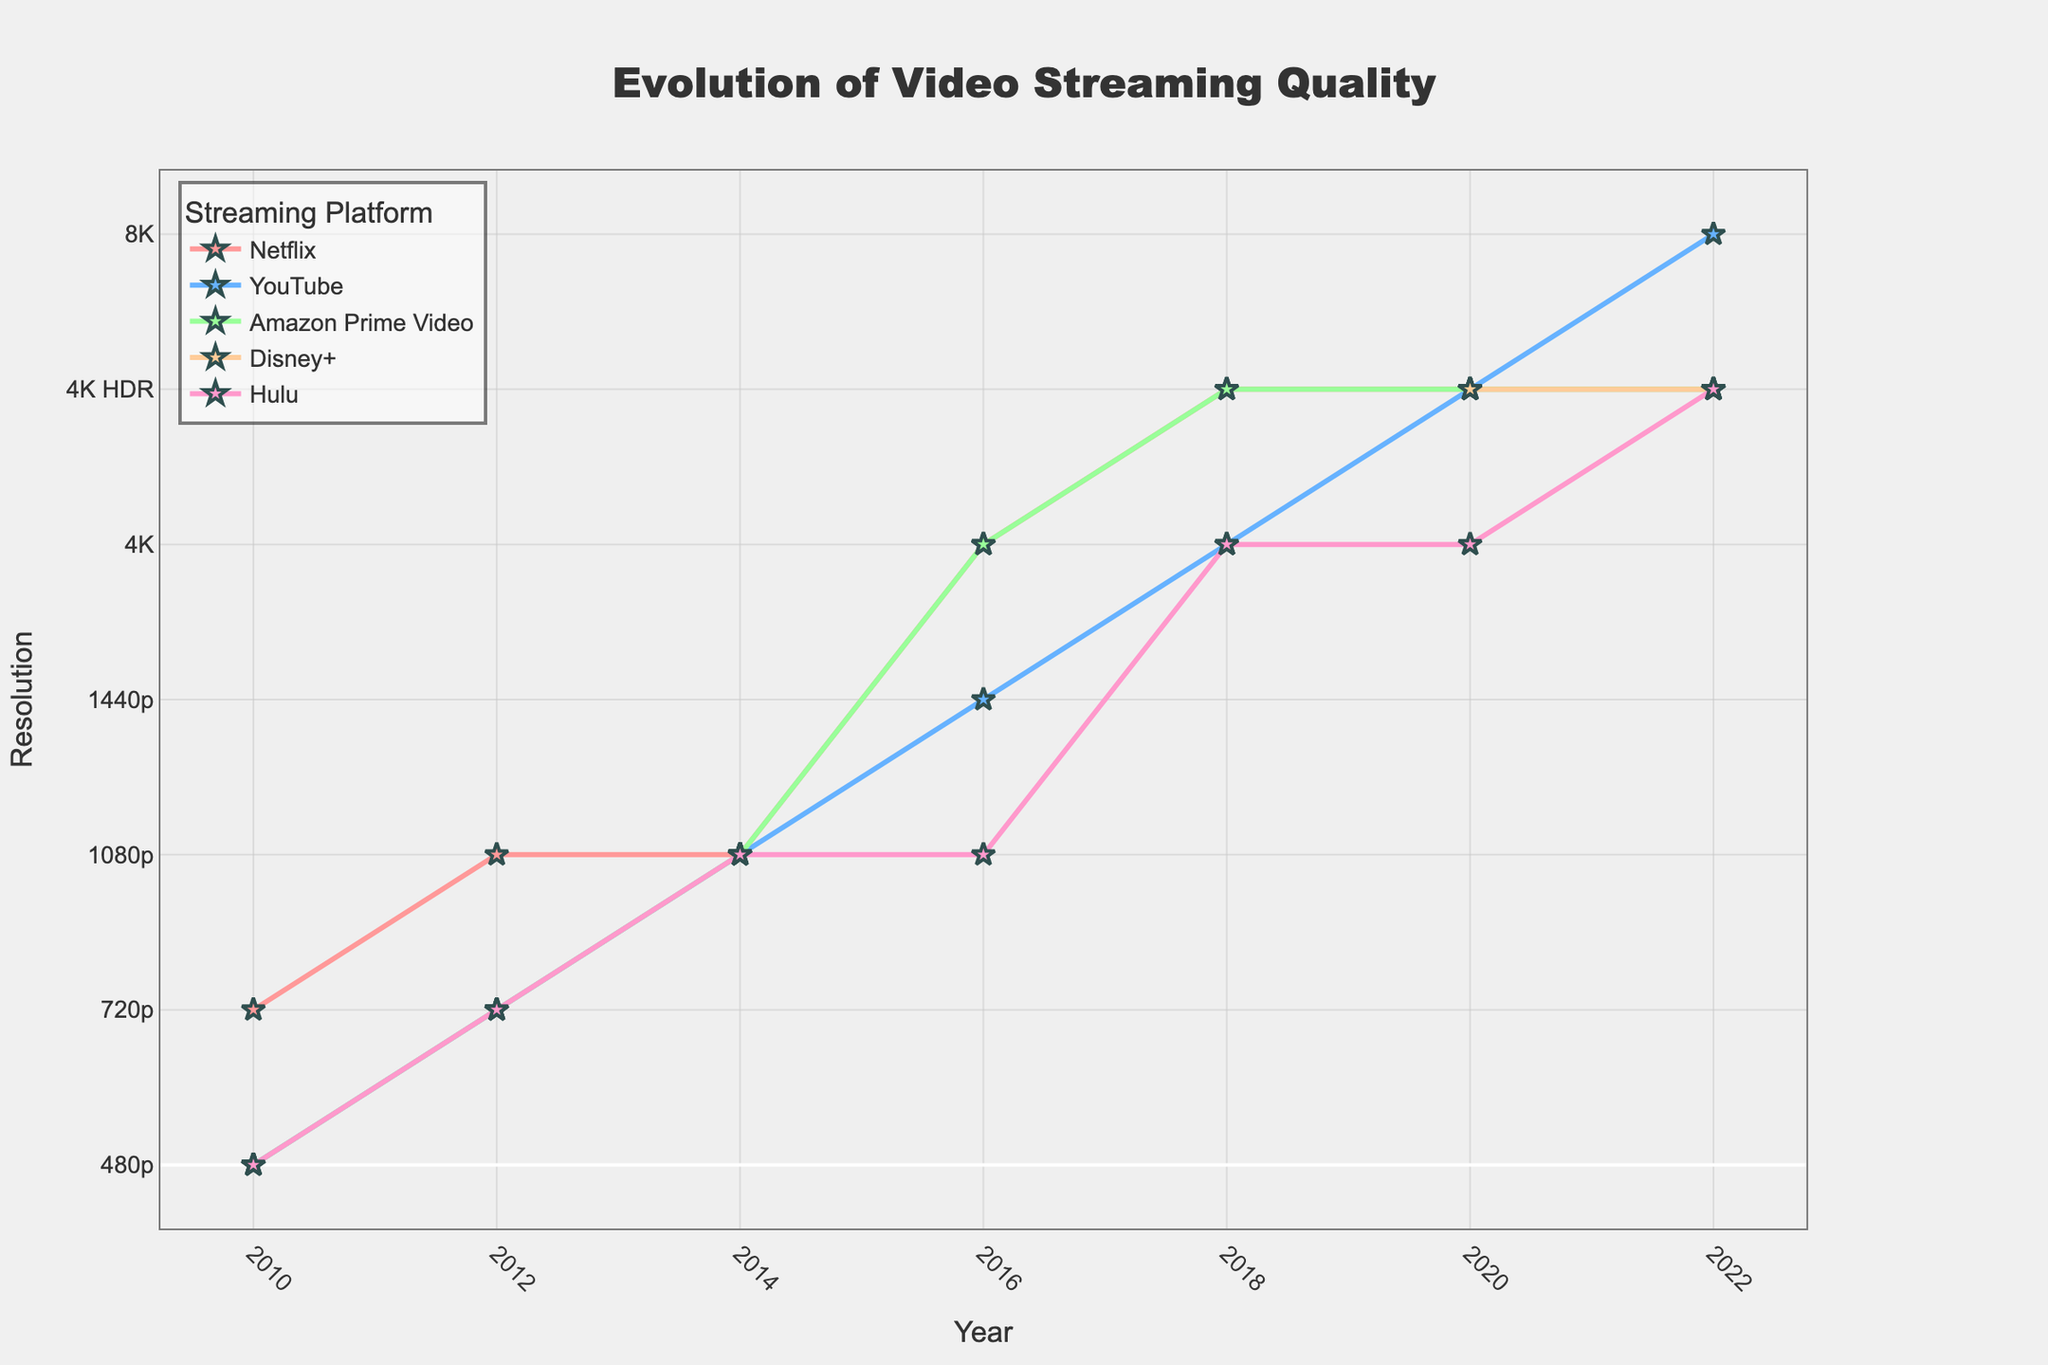Which streaming platform first offered 4K resolution? Disney+ is marked as "N/A" for earlier years, so for the remaining platforms, Netflix reaches 4K in 2016 followed by Amazon Prime Video in the same year. Disney+ is marked as "N/A" until 2020 when it offers 4K HDR, which is after Netflix and Amazon Prime Video. Thus, the first platform to offer 4K is Netflix.
Answer: Netflix Which platform was the first to offer 8K resolution? From 2010 to 2022, only YouTube shows an 8K resolution in 2022.
Answer: YouTube How did the video quality offered by Hulu improve over time? Hulu started with 480p in 2010 and progressed to 720p in 2012, 1080p in 2014, then remained at 1080p in 2016. It improved to 4K in 2018, and then to 4K HDR in 2020 and 2022.
Answer: 480p -> 720p -> 1080p -> 4K -> 4K HDR Which platforms offered resolutions higher than 1080p first, and when? Examining when each platform exceeds 1080p: Netflix offers 4K in 2016, YouTube offers 1440p in 2016, and Amazon Prime Video offers 4K in 2016. There is no data for Disney+ before 2020. Hulu stays at 1080p till 2016 and offers 4K in 2018. Therefore, both Netflix and Amazon Prime Video exceeded 1080p in 2016.
Answer: Netflix, Amazon Prime Video in 2016 Which platform had the most gradual improvement in video quality from 2010 to 2022? Comparing the progression of all platforms: Netflix steadily improves from 720p (2010) to 1080p (2012), then to 4K (2016) and ends with 4K HDR (2018 forward). YouTube progresses from 480p (2010) to 4K HDR (2020) and even jumps to 8K in 2022. Amazon Prime Video steadily increases as well, similar to Netflix. Hulu starts low at 480p (2010), progress is visible but fewer jumps compared to YouTube. Disney+ data is missing before 2020, making it less gradual. Overall, Netflix shows the most gradual improvement, consistent in its increments over the years.
Answer: Netflix What was the maximum resolution offered by Amazon Prime Video before 2016? Checking the data for Amazon Prime Video before 2016, it shows 480p in 2010, 720p in 2012, and 1080p in 2014. 4K is offered from 2016 onwards. Thus, the highest resolution before 2016 is 1080p.
Answer: 1080p Which platform showed the largest single step increase in resolution quality, and what was the step? YouTube shows increments from 480p, 720p, 1080p, to 1440p till 2016 and then jumps straight to 4K in 2018. Similar jumps are observable in other platforms. However, YouTube's jump to 8K in 2022 marks the largest single step increase from 4K HDR in 2020. This is a 4 steps jump from 4K to 8K (counting 4K, 4K HDR, and 8K itself).
Answer: YouTube, 4K HDR to 8K in 2022 